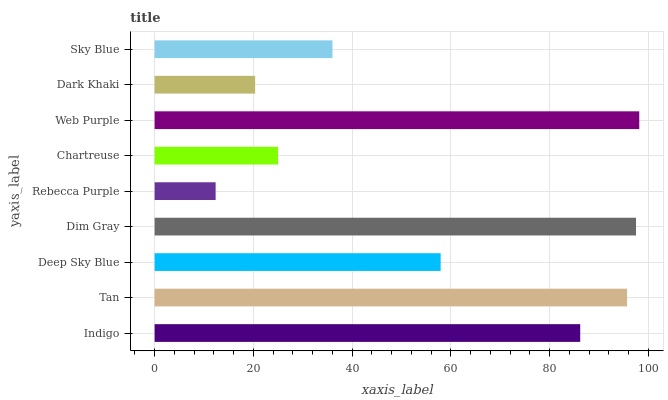Is Rebecca Purple the minimum?
Answer yes or no. Yes. Is Web Purple the maximum?
Answer yes or no. Yes. Is Tan the minimum?
Answer yes or no. No. Is Tan the maximum?
Answer yes or no. No. Is Tan greater than Indigo?
Answer yes or no. Yes. Is Indigo less than Tan?
Answer yes or no. Yes. Is Indigo greater than Tan?
Answer yes or no. No. Is Tan less than Indigo?
Answer yes or no. No. Is Deep Sky Blue the high median?
Answer yes or no. Yes. Is Deep Sky Blue the low median?
Answer yes or no. Yes. Is Tan the high median?
Answer yes or no. No. Is Indigo the low median?
Answer yes or no. No. 